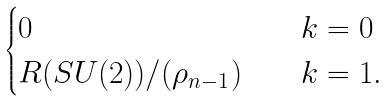Convert formula to latex. <formula><loc_0><loc_0><loc_500><loc_500>\begin{cases} 0 & \quad k = 0 \\ R ( S U ( 2 ) ) / ( \rho _ { n - 1 } ) & \quad k = 1 . \end{cases}</formula> 